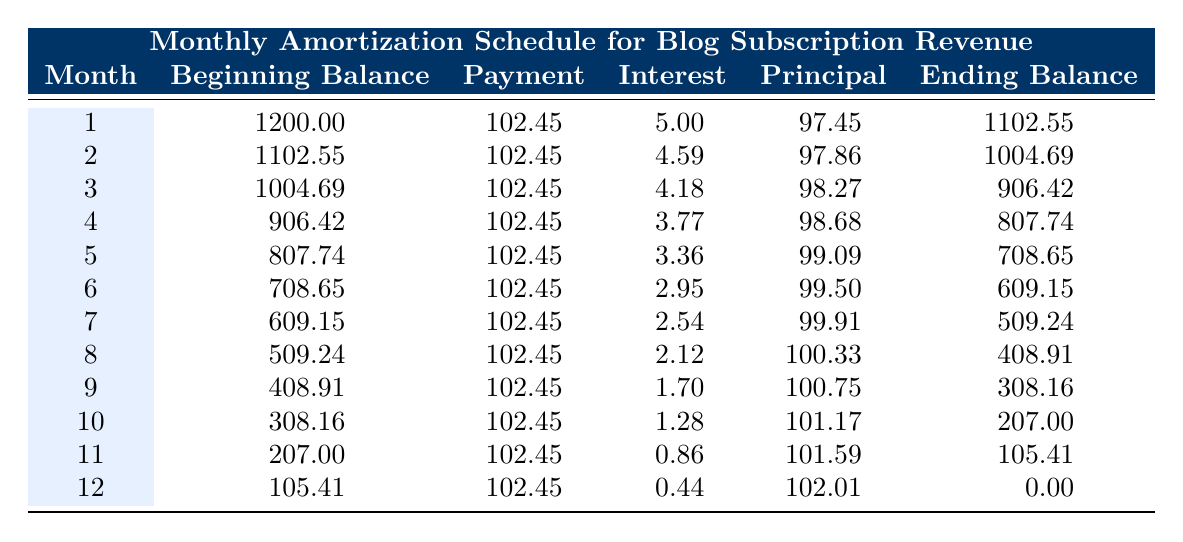What was the total payment made in the 5th month? From the table, the payment made in the 5th month is 102.45.
Answer: 102.45 What is the beginning balance for the 10th month? The beginning balance listed in the table for the 10th month is 308.16.
Answer: 308.16 Did the interest payment decrease in the 12th month compared to the 11th month? In the 11th month, the interest payment was 0.86, and in the 12th month, it was 0.44. Since 0.44 is less than 0.86, the interest payment did decrease.
Answer: Yes What is the total principal payment made over the entire loan term? To find the total principal payment, we sum the principal payments for all 12 months: (97.45 + 97.86 + 98.27 + 98.68 + 99.09 + 99.50 + 99.91 + 100.33 + 100.75 + 101.17 + 101.59 + 102.01) = 1,197.11.
Answer: 1197.11 What was the ending balance at the end of the 6th month? The ending balance for the 6th month is provided in the table as 609.15.
Answer: 609.15 How much total interest was paid over the entire loan term? To calculate the total interest paid, we sum the interest payments for all 12 months: (5.00 + 4.59 + 4.18 + 3.77 + 3.36 + 2.95 + 2.54 + 2.12 + 1.70 + 1.28 + 0.86 + 0.44) = 36.49.
Answer: 36.49 What was the highest monthly principal payment made? By examining the principal payments listed in the table, the highest principal payment of 102.01 occurred in the 12th month.
Answer: 102.01 Is the ending balance after any month greater than 1,000? Checking the ending balances, the ending balance for the 1st month was 1102.55 and the 2nd month was 1004.69, both of which are greater than 1,000.
Answer: Yes 